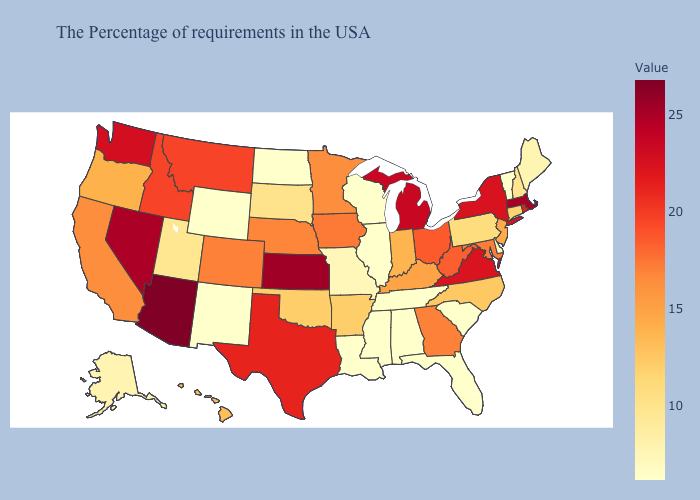Among the states that border Virginia , does Kentucky have the lowest value?
Concise answer only. No. Among the states that border New York , which have the highest value?
Concise answer only. Massachusetts. Is the legend a continuous bar?
Answer briefly. Yes. Which states have the lowest value in the USA?
Give a very brief answer. Vermont, South Carolina, Florida, Alabama, Tennessee, Wisconsin, Illinois, Mississippi, Louisiana, North Dakota, Wyoming, New Mexico. Which states have the highest value in the USA?
Keep it brief. Arizona. Among the states that border Connecticut , which have the lowest value?
Answer briefly. Rhode Island. Among the states that border Virginia , which have the highest value?
Quick response, please. West Virginia. Which states have the lowest value in the MidWest?
Short answer required. Wisconsin, Illinois, North Dakota. 